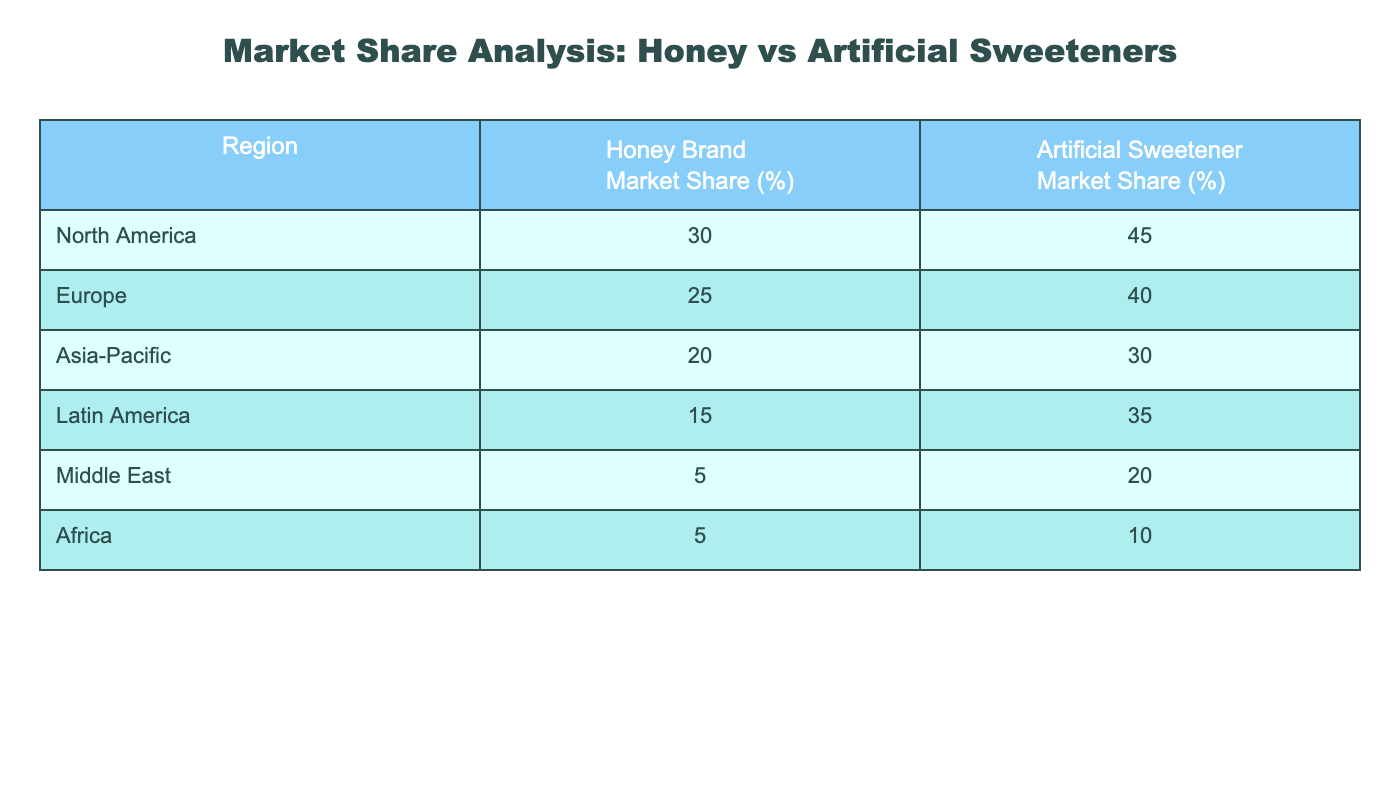What is the market share percentage of honey brands in North America? The table indicates that the market share percentage for honey brands in North America is 30%.
Answer: 30% What is the market share percentage of artificial sweeteners in Africa? The table shows that the market share percentage for artificial sweeteners in Africa is 10%.
Answer: 10% Which region has the highest market share for artificial sweeteners? The table reveals that North America has the highest market share for artificial sweeteners, at 45%.
Answer: North America Is the market share of honey brands higher in Europe than in Latin America? According to the table, the market share of honey brands in Europe is 25% and in Latin America it is 15%, making Europe higher.
Answer: Yes What is the total market share percentage of artificial sweeteners across all regions listed? To calculate the total, we sum the percentages: 45 + 40 + 30 + 35 + 20 + 10 = 180%.
Answer: 180% Which region has the lowest market share for honey brands? The table indicates that the Middle East and Africa both have the lowest market share for honey brands, at 5%.
Answer: Middle East and Africa What is the difference in market share percentage between honey brands and artificial sweeteners in the Asia-Pacific region? In the Asia-Pacific region, honey brands have a market share of 20% and artificial sweeteners have 30%. The difference is calculated as 30 - 20 = 10%.
Answer: 10% Are honey brands more popular than artificial sweeteners in Latin America? The table clearly shows that honey brands have a market share of 15% while artificial sweeteners have 35%, making sweeteners more popular in that region.
Answer: No What is the average market share percentage of honey brands across all regions? The average can be calculated by summing the values: (30 + 25 + 20 + 15 + 5 + 5) = 100, then dividing by the number of regions, which is 6, resulting in an average of 100/6 = 16.67%.
Answer: 16.67% 